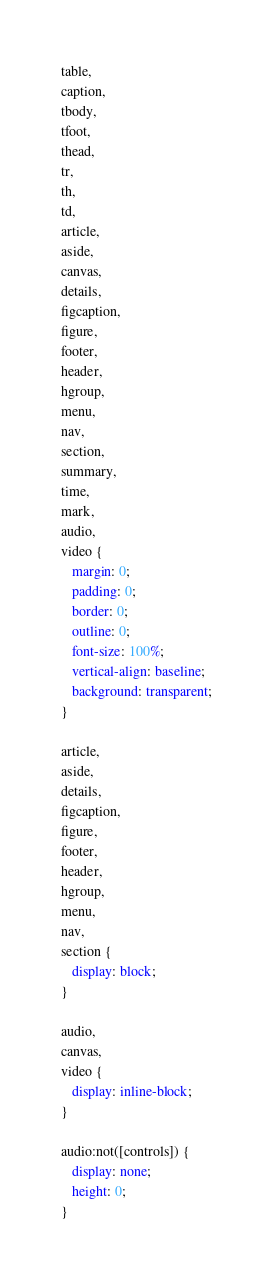<code> <loc_0><loc_0><loc_500><loc_500><_CSS_>table,
caption,
tbody,
tfoot,
thead,
tr,
th,
td,
article,
aside,
canvas,
details,
figcaption,
figure,
footer,
header,
hgroup,
menu,
nav,
section,
summary,
time,
mark,
audio,
video {
   margin: 0;
   padding: 0;
   border: 0;
   outline: 0;
   font-size: 100%;
   vertical-align: baseline;
   background: transparent;
}

article,
aside,
details,
figcaption,
figure,
footer,
header,
hgroup,
menu,
nav,
section {
   display: block;
}

audio,
canvas,
video {
   display: inline-block;
}

audio:not([controls]) {
   display: none;
   height: 0;
}
</code> 